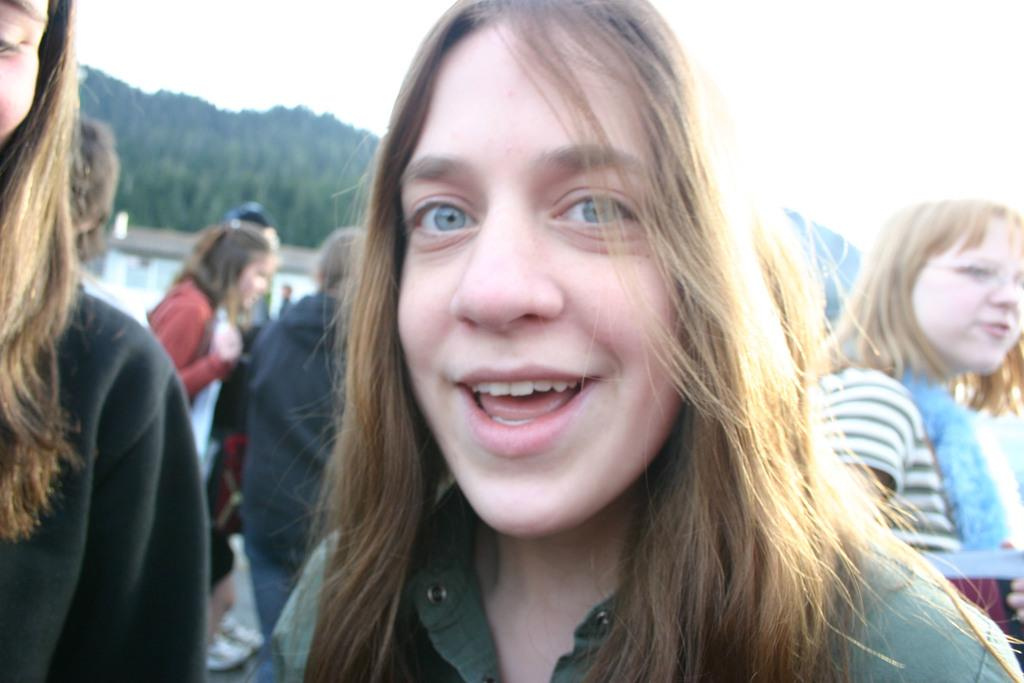What is happening in the image? There are groups of persons standing in the image. Can you describe the person in the front? There is a person standing and smiling in the front. Are there any other persons visible in the image? Yes, there are persons visible in the background. What can be seen in the background of the image? There are trees in the background. What type of hat is the doll wearing in the image? There is no doll present in the image, so it is not possible to determine what type of hat it might be wearing. 